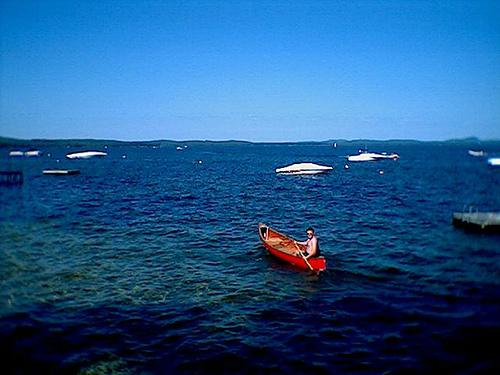Question: why was this photo taken?
Choices:
A. For a magazine.
B. To remember the day.
C. For a movie scene.
D. For a wedding invitation.
Answer with the letter. Answer: A Question: what is the weather like?
Choices:
A. Cloudy.
B. Sunny.
C. Hot.
D. Stormy.
Answer with the letter. Answer: B 